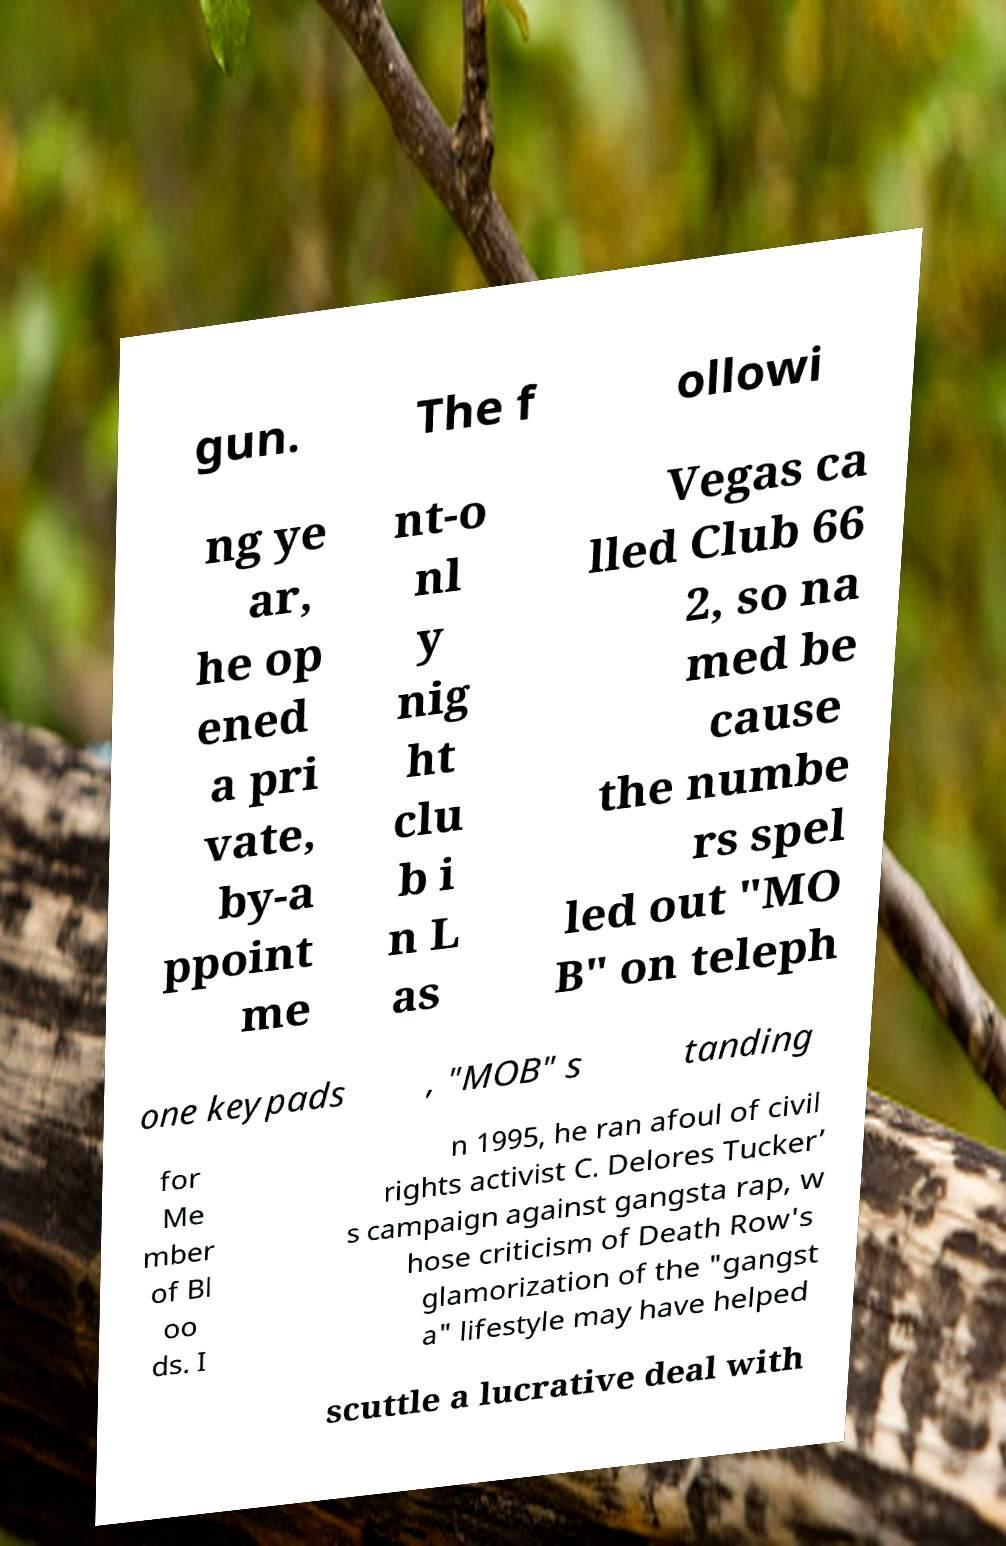I need the written content from this picture converted into text. Can you do that? gun. The f ollowi ng ye ar, he op ened a pri vate, by-a ppoint me nt-o nl y nig ht clu b i n L as Vegas ca lled Club 66 2, so na med be cause the numbe rs spel led out "MO B" on teleph one keypads , "MOB" s tanding for Me mber of Bl oo ds. I n 1995, he ran afoul of civil rights activist C. Delores Tucker’ s campaign against gangsta rap, w hose criticism of Death Row's glamorization of the "gangst a" lifestyle may have helped scuttle a lucrative deal with 